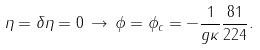Convert formula to latex. <formula><loc_0><loc_0><loc_500><loc_500>\eta = \delta \eta = 0 \, \rightarrow \, \phi = \phi _ { c } = - \frac { 1 } { g \kappa } \frac { 8 1 } { 2 2 4 } .</formula> 